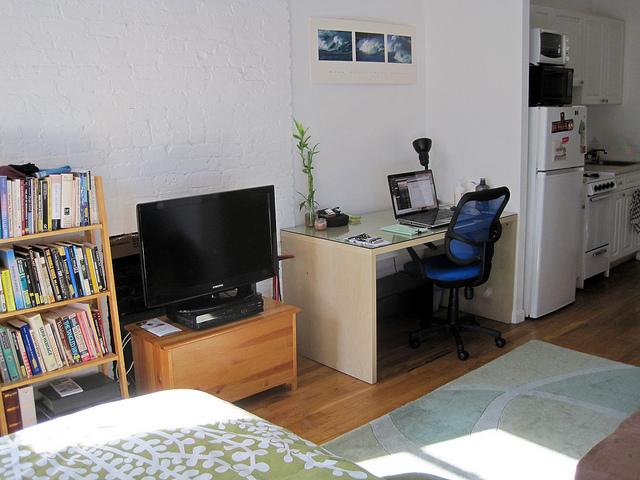Is this a picture of a studio apartment?
Keep it brief. Yes. What color is the computer chair?
Answer briefly. Blue. Where are the books?
Keep it brief. On shelf. 